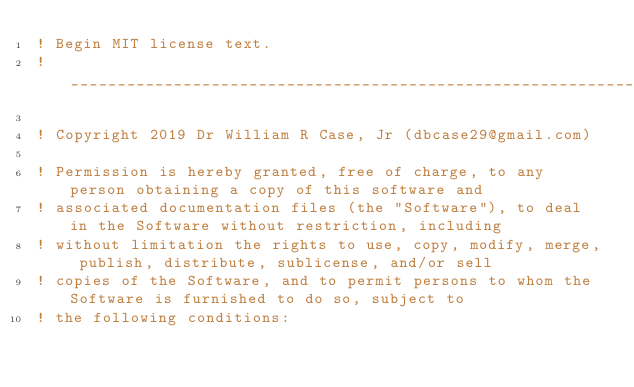<code> <loc_0><loc_0><loc_500><loc_500><_FORTRAN_>! Begin MIT license text.                                                                                    
! _______________________________________________________________________________________________________
                                                                                                         
! Copyright 2019 Dr William R Case, Jr (dbcase29@gmail.com)                                              
                                                                                                         
! Permission is hereby granted, free of charge, to any person obtaining a copy of this software and      
! associated documentation files (the "Software"), to deal in the Software without restriction, including
! without limitation the rights to use, copy, modify, merge, publish, distribute, sublicense, and/or sell
! copies of the Software, and to permit persons to whom the Software is furnished to do so, subject to   
! the following conditions:                                                                              </code> 